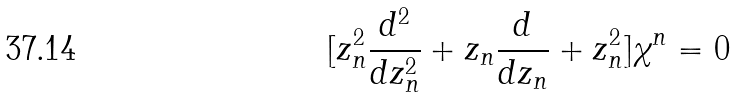<formula> <loc_0><loc_0><loc_500><loc_500>[ z _ { n } ^ { 2 } \frac { d ^ { 2 } } { d z _ { n } ^ { 2 } } + z _ { n } \frac { d } { d z _ { n } } + z _ { n } ^ { 2 } ] \chi ^ { n } = 0</formula> 